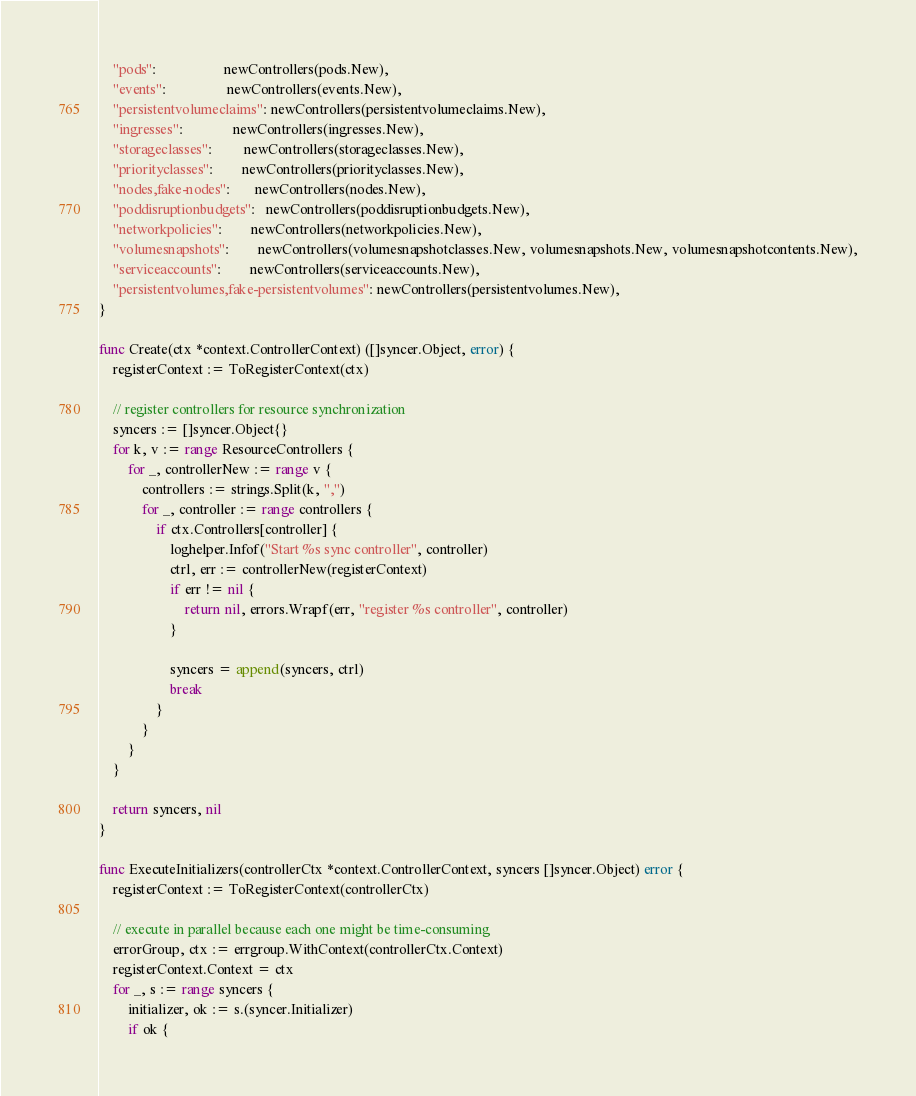Convert code to text. <code><loc_0><loc_0><loc_500><loc_500><_Go_>	"pods":                   newControllers(pods.New),
	"events":                 newControllers(events.New),
	"persistentvolumeclaims": newControllers(persistentvolumeclaims.New),
	"ingresses":              newControllers(ingresses.New),
	"storageclasses":         newControllers(storageclasses.New),
	"priorityclasses":        newControllers(priorityclasses.New),
	"nodes,fake-nodes":       newControllers(nodes.New),
	"poddisruptionbudgets":   newControllers(poddisruptionbudgets.New),
	"networkpolicies":        newControllers(networkpolicies.New),
	"volumesnapshots":        newControllers(volumesnapshotclasses.New, volumesnapshots.New, volumesnapshotcontents.New),
	"serviceaccounts":        newControllers(serviceaccounts.New),
	"persistentvolumes,fake-persistentvolumes": newControllers(persistentvolumes.New),
}

func Create(ctx *context.ControllerContext) ([]syncer.Object, error) {
	registerContext := ToRegisterContext(ctx)

	// register controllers for resource synchronization
	syncers := []syncer.Object{}
	for k, v := range ResourceControllers {
		for _, controllerNew := range v {
			controllers := strings.Split(k, ",")
			for _, controller := range controllers {
				if ctx.Controllers[controller] {
					loghelper.Infof("Start %s sync controller", controller)
					ctrl, err := controllerNew(registerContext)
					if err != nil {
						return nil, errors.Wrapf(err, "register %s controller", controller)
					}

					syncers = append(syncers, ctrl)
					break
				}
			}
		}
	}

	return syncers, nil
}

func ExecuteInitializers(controllerCtx *context.ControllerContext, syncers []syncer.Object) error {
	registerContext := ToRegisterContext(controllerCtx)

	// execute in parallel because each one might be time-consuming
	errorGroup, ctx := errgroup.WithContext(controllerCtx.Context)
	registerContext.Context = ctx
	for _, s := range syncers {
		initializer, ok := s.(syncer.Initializer)
		if ok {</code> 